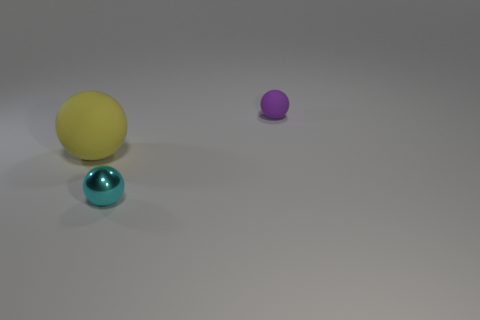Subtract all big yellow matte spheres. How many spheres are left? 2 Add 3 purple matte things. How many objects exist? 6 Subtract all green spheres. Subtract all purple blocks. How many spheres are left? 3 Subtract all yellow rubber balls. Subtract all big balls. How many objects are left? 1 Add 1 purple things. How many purple things are left? 2 Add 3 blue cubes. How many blue cubes exist? 3 Subtract 0 gray cylinders. How many objects are left? 3 